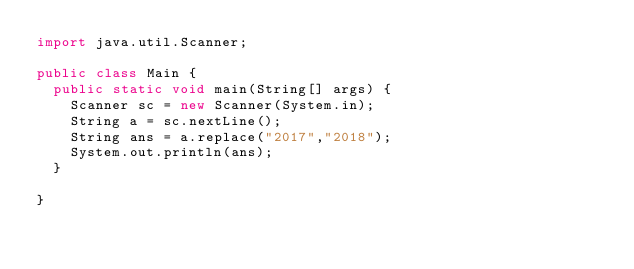<code> <loc_0><loc_0><loc_500><loc_500><_Java_>import java.util.Scanner;

public class Main {
  public static void main(String[] args) {
    Scanner sc = new Scanner(System.in);
    String a = sc.nextLine();
    String ans = a.replace("2017","2018");
    System.out.println(ans);
  }

}
</code> 